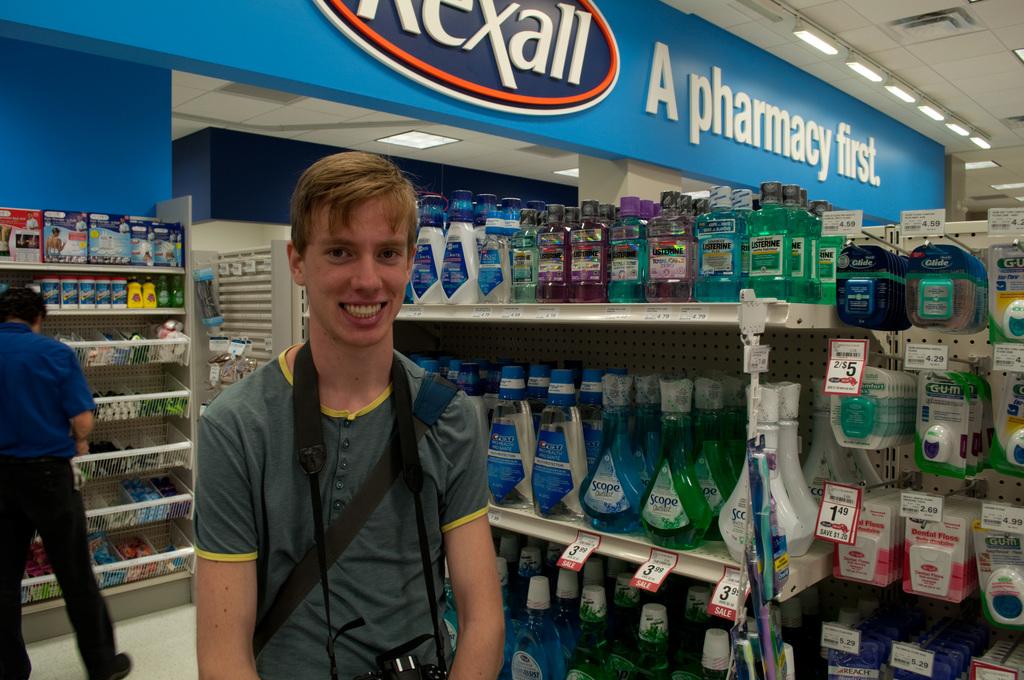What kind of store was this picture taken in?
Your answer should be compact. Pharmacy. Does this store sell scope?
Offer a terse response. Yes. 